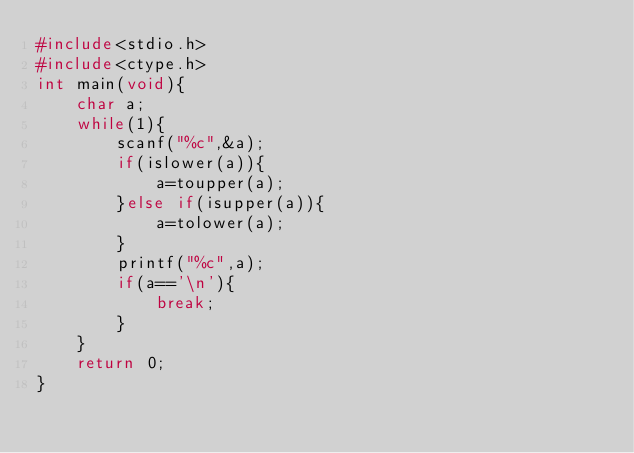<code> <loc_0><loc_0><loc_500><loc_500><_C_>#include<stdio.h>
#include<ctype.h>
int main(void){
    char a;
    while(1){
        scanf("%c",&a);
        if(islower(a)){
            a=toupper(a);
        }else if(isupper(a)){
            a=tolower(a);
        }
        printf("%c",a);
        if(a=='\n'){
            break;
        }
    }
    return 0;
}</code> 